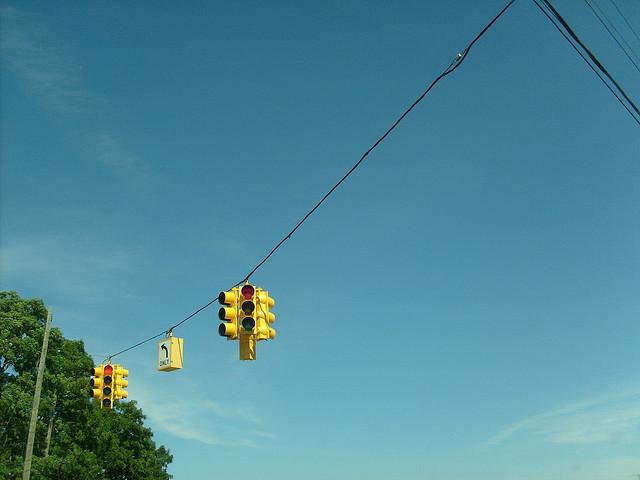What is the purpose of the arrow?
Concise answer only. Left turn only. Is this an intersection?
Answer briefly. Yes. Why are there so many lights?
Keep it brief. I don't know. 